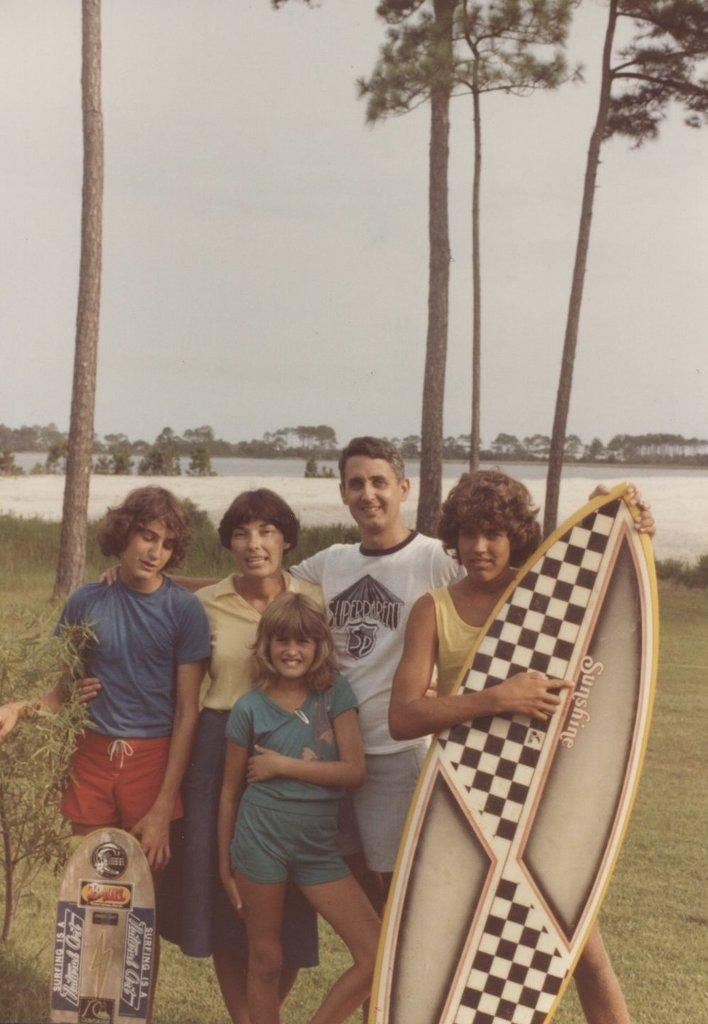How many people are in the image? There are 5 persons in the image. Can you describe the expressions of the people in the image? Two of the persons are smiling. What is the woman holding in the image? The woman is holding a ski board. What can be seen in the background of the image? There are trees, plants, and grass in the background of the image. How many roots can be seen growing from the sack in the image? There is no sack or roots present in the image. How many girls are in the image? The provided facts do not specify the gender of the people in the image, so we cannot definitively answer how many girls are present. 